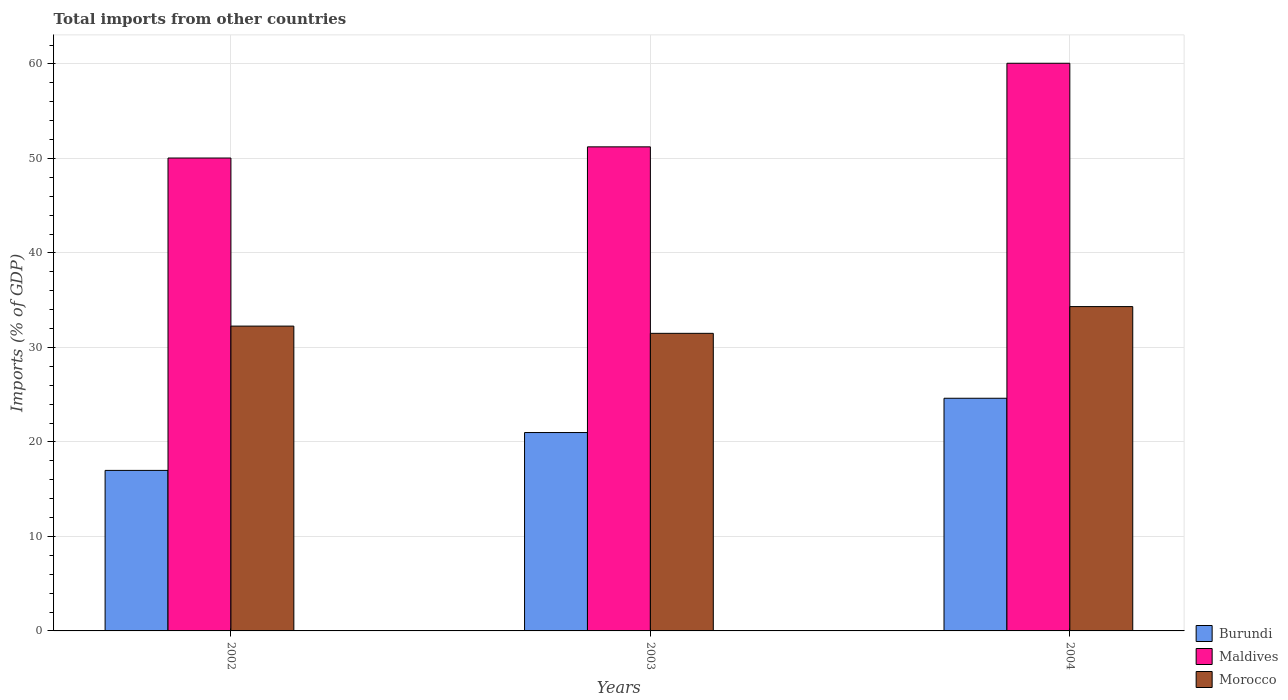How many different coloured bars are there?
Offer a very short reply. 3. What is the label of the 2nd group of bars from the left?
Make the answer very short. 2003. In how many cases, is the number of bars for a given year not equal to the number of legend labels?
Keep it short and to the point. 0. What is the total imports in Burundi in 2003?
Make the answer very short. 20.99. Across all years, what is the maximum total imports in Burundi?
Provide a succinct answer. 24.62. Across all years, what is the minimum total imports in Maldives?
Make the answer very short. 50.05. In which year was the total imports in Morocco maximum?
Make the answer very short. 2004. What is the total total imports in Maldives in the graph?
Your response must be concise. 161.35. What is the difference between the total imports in Morocco in 2003 and that in 2004?
Ensure brevity in your answer.  -2.83. What is the difference between the total imports in Burundi in 2003 and the total imports in Maldives in 2002?
Your response must be concise. -29.05. What is the average total imports in Morocco per year?
Provide a short and direct response. 32.69. In the year 2003, what is the difference between the total imports in Maldives and total imports in Burundi?
Make the answer very short. 30.23. In how many years, is the total imports in Burundi greater than 28 %?
Your answer should be compact. 0. What is the ratio of the total imports in Burundi in 2002 to that in 2003?
Your response must be concise. 0.81. Is the total imports in Morocco in 2003 less than that in 2004?
Give a very brief answer. Yes. Is the difference between the total imports in Maldives in 2002 and 2003 greater than the difference between the total imports in Burundi in 2002 and 2003?
Your answer should be very brief. Yes. What is the difference between the highest and the second highest total imports in Maldives?
Offer a terse response. 8.85. What is the difference between the highest and the lowest total imports in Maldives?
Give a very brief answer. 10.03. Is the sum of the total imports in Burundi in 2002 and 2004 greater than the maximum total imports in Morocco across all years?
Give a very brief answer. Yes. What does the 2nd bar from the left in 2004 represents?
Offer a very short reply. Maldives. What does the 1st bar from the right in 2002 represents?
Your response must be concise. Morocco. Is it the case that in every year, the sum of the total imports in Maldives and total imports in Burundi is greater than the total imports in Morocco?
Your answer should be compact. Yes. How many bars are there?
Keep it short and to the point. 9. How many years are there in the graph?
Make the answer very short. 3. What is the difference between two consecutive major ticks on the Y-axis?
Provide a short and direct response. 10. Does the graph contain grids?
Provide a succinct answer. Yes. Where does the legend appear in the graph?
Offer a terse response. Bottom right. How many legend labels are there?
Your answer should be very brief. 3. How are the legend labels stacked?
Provide a succinct answer. Vertical. What is the title of the graph?
Keep it short and to the point. Total imports from other countries. Does "Poland" appear as one of the legend labels in the graph?
Your answer should be very brief. No. What is the label or title of the X-axis?
Make the answer very short. Years. What is the label or title of the Y-axis?
Your response must be concise. Imports (% of GDP). What is the Imports (% of GDP) of Burundi in 2002?
Keep it short and to the point. 16.99. What is the Imports (% of GDP) in Maldives in 2002?
Ensure brevity in your answer.  50.05. What is the Imports (% of GDP) of Morocco in 2002?
Give a very brief answer. 32.26. What is the Imports (% of GDP) in Burundi in 2003?
Provide a short and direct response. 20.99. What is the Imports (% of GDP) in Maldives in 2003?
Offer a terse response. 51.23. What is the Imports (% of GDP) of Morocco in 2003?
Offer a very short reply. 31.49. What is the Imports (% of GDP) of Burundi in 2004?
Make the answer very short. 24.62. What is the Imports (% of GDP) of Maldives in 2004?
Your response must be concise. 60.08. What is the Imports (% of GDP) of Morocco in 2004?
Ensure brevity in your answer.  34.32. Across all years, what is the maximum Imports (% of GDP) in Burundi?
Ensure brevity in your answer.  24.62. Across all years, what is the maximum Imports (% of GDP) in Maldives?
Your answer should be compact. 60.08. Across all years, what is the maximum Imports (% of GDP) in Morocco?
Your answer should be compact. 34.32. Across all years, what is the minimum Imports (% of GDP) in Burundi?
Your answer should be very brief. 16.99. Across all years, what is the minimum Imports (% of GDP) of Maldives?
Provide a succinct answer. 50.05. Across all years, what is the minimum Imports (% of GDP) of Morocco?
Offer a very short reply. 31.49. What is the total Imports (% of GDP) of Burundi in the graph?
Provide a succinct answer. 62.61. What is the total Imports (% of GDP) of Maldives in the graph?
Offer a very short reply. 161.35. What is the total Imports (% of GDP) in Morocco in the graph?
Offer a very short reply. 98.08. What is the difference between the Imports (% of GDP) in Burundi in 2002 and that in 2003?
Offer a terse response. -4.01. What is the difference between the Imports (% of GDP) of Maldives in 2002 and that in 2003?
Your answer should be compact. -1.18. What is the difference between the Imports (% of GDP) in Morocco in 2002 and that in 2003?
Your answer should be very brief. 0.77. What is the difference between the Imports (% of GDP) of Burundi in 2002 and that in 2004?
Give a very brief answer. -7.64. What is the difference between the Imports (% of GDP) in Maldives in 2002 and that in 2004?
Make the answer very short. -10.03. What is the difference between the Imports (% of GDP) of Morocco in 2002 and that in 2004?
Provide a short and direct response. -2.06. What is the difference between the Imports (% of GDP) in Burundi in 2003 and that in 2004?
Your response must be concise. -3.63. What is the difference between the Imports (% of GDP) in Maldives in 2003 and that in 2004?
Your answer should be compact. -8.85. What is the difference between the Imports (% of GDP) in Morocco in 2003 and that in 2004?
Your answer should be very brief. -2.83. What is the difference between the Imports (% of GDP) in Burundi in 2002 and the Imports (% of GDP) in Maldives in 2003?
Give a very brief answer. -34.24. What is the difference between the Imports (% of GDP) in Burundi in 2002 and the Imports (% of GDP) in Morocco in 2003?
Your answer should be compact. -14.51. What is the difference between the Imports (% of GDP) of Maldives in 2002 and the Imports (% of GDP) of Morocco in 2003?
Make the answer very short. 18.55. What is the difference between the Imports (% of GDP) in Burundi in 2002 and the Imports (% of GDP) in Maldives in 2004?
Give a very brief answer. -43.09. What is the difference between the Imports (% of GDP) of Burundi in 2002 and the Imports (% of GDP) of Morocco in 2004?
Provide a short and direct response. -17.34. What is the difference between the Imports (% of GDP) of Maldives in 2002 and the Imports (% of GDP) of Morocco in 2004?
Provide a succinct answer. 15.72. What is the difference between the Imports (% of GDP) in Burundi in 2003 and the Imports (% of GDP) in Maldives in 2004?
Keep it short and to the point. -39.08. What is the difference between the Imports (% of GDP) of Burundi in 2003 and the Imports (% of GDP) of Morocco in 2004?
Your response must be concise. -13.33. What is the difference between the Imports (% of GDP) of Maldives in 2003 and the Imports (% of GDP) of Morocco in 2004?
Ensure brevity in your answer.  16.91. What is the average Imports (% of GDP) in Burundi per year?
Your answer should be compact. 20.87. What is the average Imports (% of GDP) of Maldives per year?
Ensure brevity in your answer.  53.78. What is the average Imports (% of GDP) in Morocco per year?
Offer a terse response. 32.69. In the year 2002, what is the difference between the Imports (% of GDP) in Burundi and Imports (% of GDP) in Maldives?
Make the answer very short. -33.06. In the year 2002, what is the difference between the Imports (% of GDP) of Burundi and Imports (% of GDP) of Morocco?
Ensure brevity in your answer.  -15.27. In the year 2002, what is the difference between the Imports (% of GDP) in Maldives and Imports (% of GDP) in Morocco?
Offer a very short reply. 17.79. In the year 2003, what is the difference between the Imports (% of GDP) in Burundi and Imports (% of GDP) in Maldives?
Offer a very short reply. -30.23. In the year 2003, what is the difference between the Imports (% of GDP) of Burundi and Imports (% of GDP) of Morocco?
Your response must be concise. -10.5. In the year 2003, what is the difference between the Imports (% of GDP) in Maldives and Imports (% of GDP) in Morocco?
Ensure brevity in your answer.  19.74. In the year 2004, what is the difference between the Imports (% of GDP) of Burundi and Imports (% of GDP) of Maldives?
Your answer should be very brief. -35.45. In the year 2004, what is the difference between the Imports (% of GDP) of Burundi and Imports (% of GDP) of Morocco?
Ensure brevity in your answer.  -9.7. In the year 2004, what is the difference between the Imports (% of GDP) of Maldives and Imports (% of GDP) of Morocco?
Your answer should be compact. 25.75. What is the ratio of the Imports (% of GDP) of Burundi in 2002 to that in 2003?
Your answer should be very brief. 0.81. What is the ratio of the Imports (% of GDP) in Maldives in 2002 to that in 2003?
Your answer should be very brief. 0.98. What is the ratio of the Imports (% of GDP) of Morocco in 2002 to that in 2003?
Make the answer very short. 1.02. What is the ratio of the Imports (% of GDP) of Burundi in 2002 to that in 2004?
Make the answer very short. 0.69. What is the ratio of the Imports (% of GDP) in Maldives in 2002 to that in 2004?
Your response must be concise. 0.83. What is the ratio of the Imports (% of GDP) of Morocco in 2002 to that in 2004?
Ensure brevity in your answer.  0.94. What is the ratio of the Imports (% of GDP) in Burundi in 2003 to that in 2004?
Your response must be concise. 0.85. What is the ratio of the Imports (% of GDP) in Maldives in 2003 to that in 2004?
Keep it short and to the point. 0.85. What is the ratio of the Imports (% of GDP) in Morocco in 2003 to that in 2004?
Ensure brevity in your answer.  0.92. What is the difference between the highest and the second highest Imports (% of GDP) in Burundi?
Keep it short and to the point. 3.63. What is the difference between the highest and the second highest Imports (% of GDP) of Maldives?
Offer a terse response. 8.85. What is the difference between the highest and the second highest Imports (% of GDP) in Morocco?
Provide a short and direct response. 2.06. What is the difference between the highest and the lowest Imports (% of GDP) of Burundi?
Provide a succinct answer. 7.64. What is the difference between the highest and the lowest Imports (% of GDP) in Maldives?
Offer a terse response. 10.03. What is the difference between the highest and the lowest Imports (% of GDP) in Morocco?
Keep it short and to the point. 2.83. 